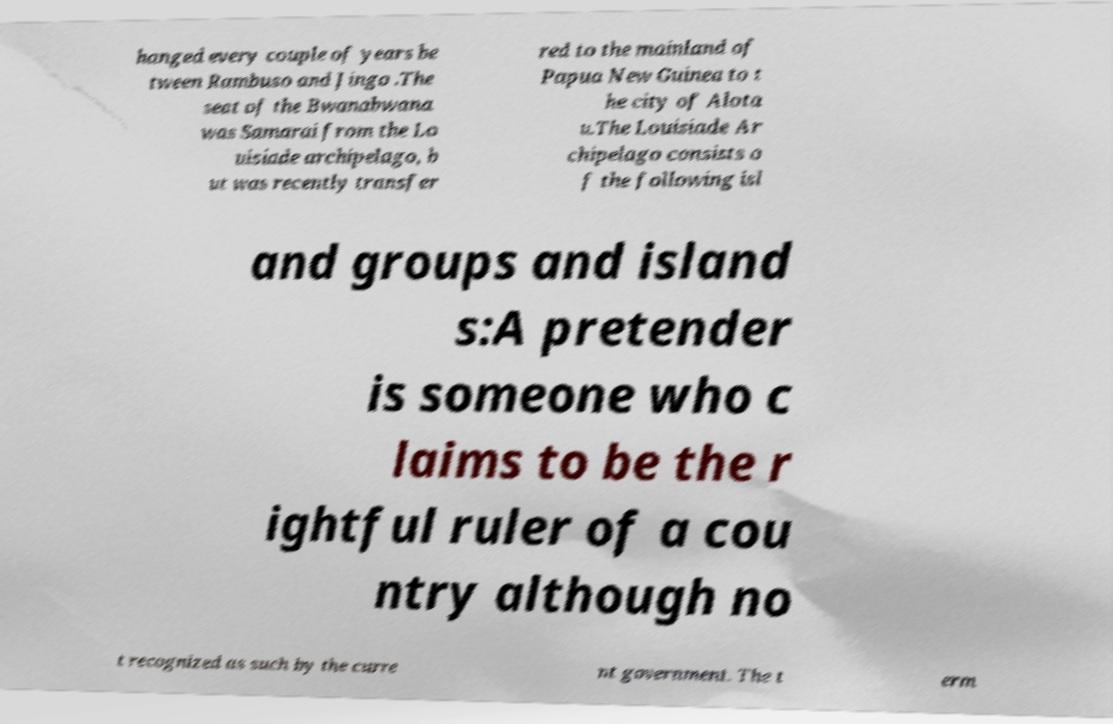For documentation purposes, I need the text within this image transcribed. Could you provide that? hanged every couple of years be tween Rambuso and Jingo .The seat of the Bwanabwana was Samarai from the Lo uisiade archipelago, b ut was recently transfer red to the mainland of Papua New Guinea to t he city of Alota u.The Louisiade Ar chipelago consists o f the following isl and groups and island s:A pretender is someone who c laims to be the r ightful ruler of a cou ntry although no t recognized as such by the curre nt government. The t erm 